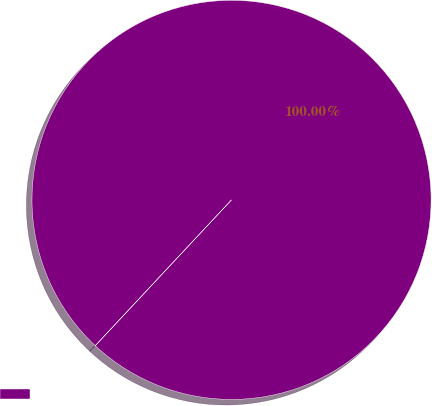<chart> <loc_0><loc_0><loc_500><loc_500><pie_chart><ecel><nl><fcel>100.0%<nl></chart> 